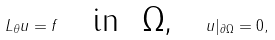<formula> <loc_0><loc_0><loc_500><loc_500>L _ { \theta } u = f \text { } \text { } \text { in } \text { $\Omega$, } \text { } \text { } u | _ { \partial \Omega } = 0 ,</formula> 